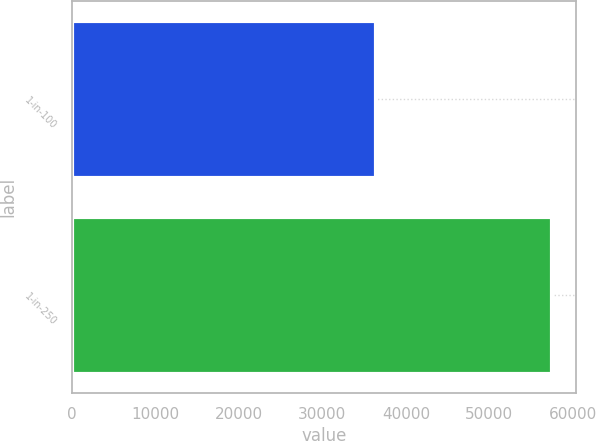Convert chart to OTSL. <chart><loc_0><loc_0><loc_500><loc_500><bar_chart><fcel>1-in-100<fcel>1-in-250<nl><fcel>36456<fcel>57486<nl></chart> 